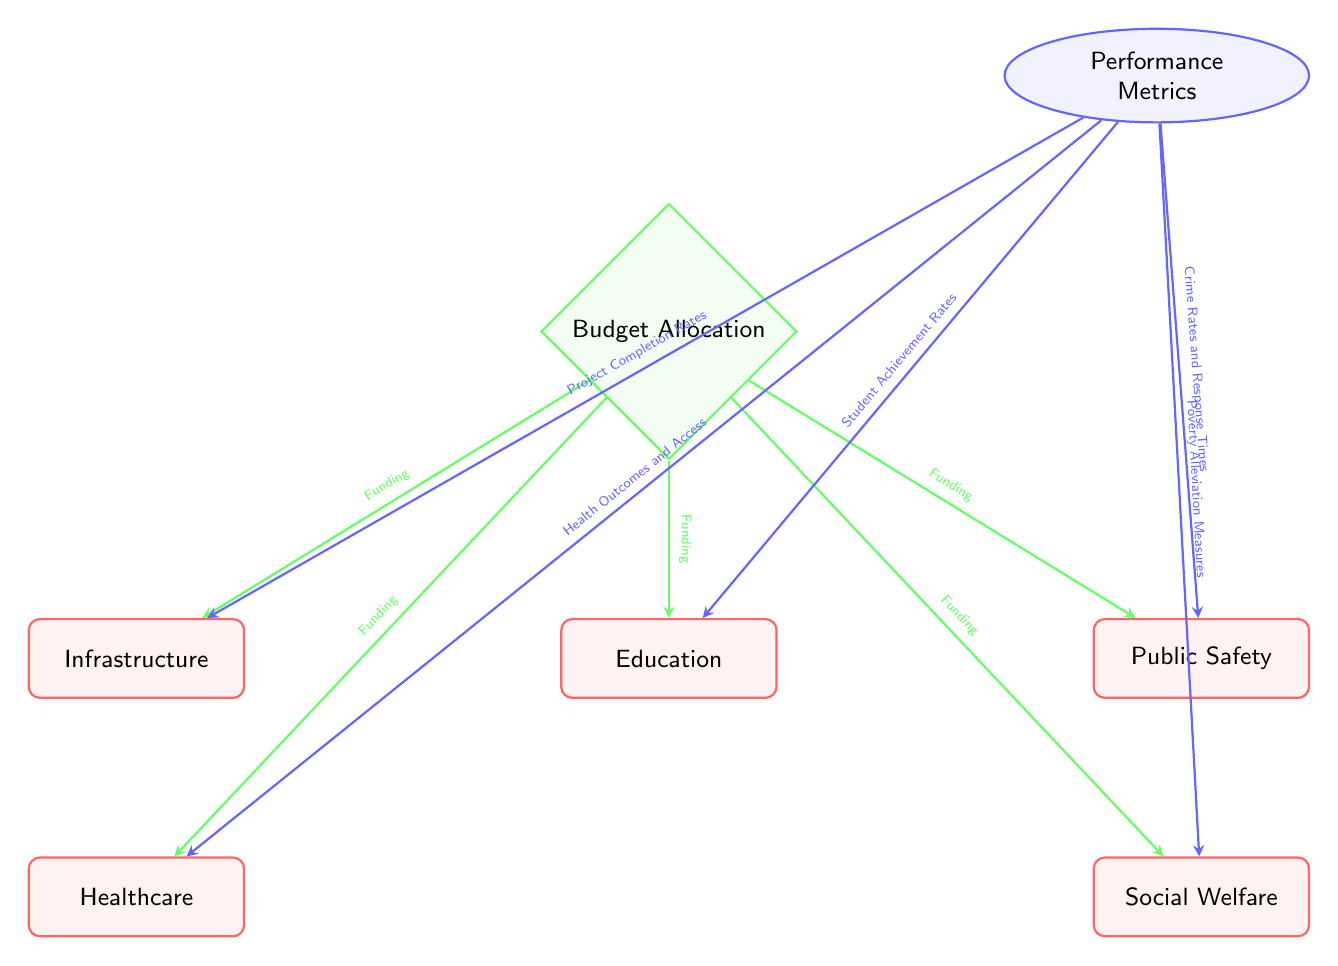What are the services included in the budget allocation? The diagram lists five services under Budget Allocation: Education, Healthcare, Infrastructure, Public Safety, and Social Welfare. These services are visually represented below the Budget Allocation node.
Answer: Education, Healthcare, Infrastructure, Public Safety, Social Welfare How many performance metrics are displayed? The diagram shows five performance metrics connected to the Performance Metrics node: Student Achievement Rates, Health Outcomes and Access, Project Completion Rates, Crime Rates and Response Times, and Poverty Alleviation Measures. The count is determined by the number of arrows leading from the metrics node.
Answer: 5 Which service has a performance metric related to crime? The Public Safety service is associated with the performance metric Crime Rates and Response Times, as indicated by the arrow connecting the Performance Metrics node to the Public Safety node.
Answer: Public Safety What type of shape represents the Budget Allocation in this diagram? The Budget Allocation is represented by a diamond shape, as indicated by the specific style definition for the allocation node in the diagram.
Answer: Diamond What does the arrow from Budget Allocation to Education signify? The arrow indicates Funding going from the Budget Allocation node to the Education service, representing the financial support allocated to education.
Answer: Funding Name one performance metric related to healthcare. The performance metric Health Outcomes and Access is related to the Healthcare service, as shown by the arrow from the Performance Metrics node to the Healthcare node.
Answer: Health Outcomes and Access Which two services are connected to the performance metrics node by the same funding arrow? The Healthcare and Education services are both connected to the Budget Allocation node by individual funding arrows. This can be observed as they are both positioned below the Budget Allocation node, with separate arrows leading to them.
Answer: Healthcare, Education How many distinct arrows are shown in the diagram? There are ten distinct arrows in total: five leading from the Budget Allocation to each service and five from the Performance Metrics to each service. The total is calculated by counting these connections in the diagram.
Answer: 10 What indicates the flow of funding in the diagram? The green arrows point from the Budget Allocation to each of the services, indicating the flow of funding towards these public services as they connect through those arrows.
Answer: Green arrows 